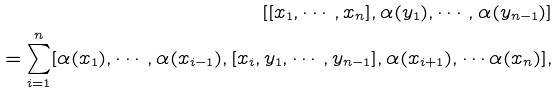<formula> <loc_0><loc_0><loc_500><loc_500>[ [ x _ { 1 } , \cdots , x _ { n } ] , \alpha ( y _ { 1 } ) , \cdots , \alpha ( y _ { n - 1 } ) ] \\ = \sum _ { i = 1 } ^ { n } [ \alpha ( x _ { 1 } ) , \cdots , \alpha ( x _ { i - 1 } ) , [ x _ { i } , y _ { 1 } , \cdots , y _ { n - 1 } ] , \alpha ( x _ { i + 1 } ) , \cdots \alpha ( x _ { n } ) ] ,</formula> 